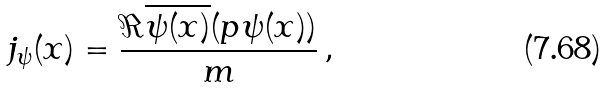<formula> <loc_0><loc_0><loc_500><loc_500>j _ { \psi } ( x ) = \frac { \Re \overline { \psi ( x ) } ( p \psi ( x ) ) } { m } \, ,</formula> 